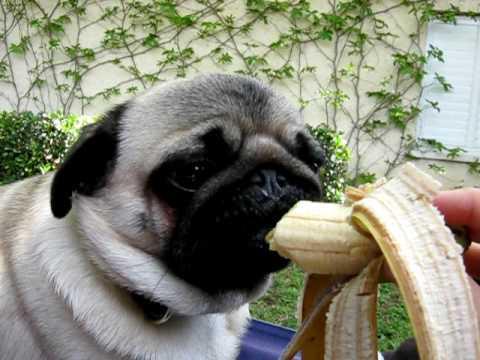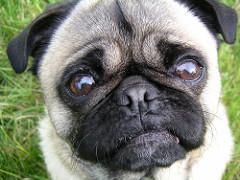The first image is the image on the left, the second image is the image on the right. Examine the images to the left and right. Is the description "The dog in the image on the right is being offered a banana." accurate? Answer yes or no. No. The first image is the image on the left, the second image is the image on the right. Considering the images on both sides, is "All dogs shown are outdoors, and a hand is visible reaching from the right to offer a pug a banana in one image." valid? Answer yes or no. Yes. 